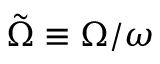<formula> <loc_0><loc_0><loc_500><loc_500>\tilde { \Omega } \equiv \Omega / \omega</formula> 